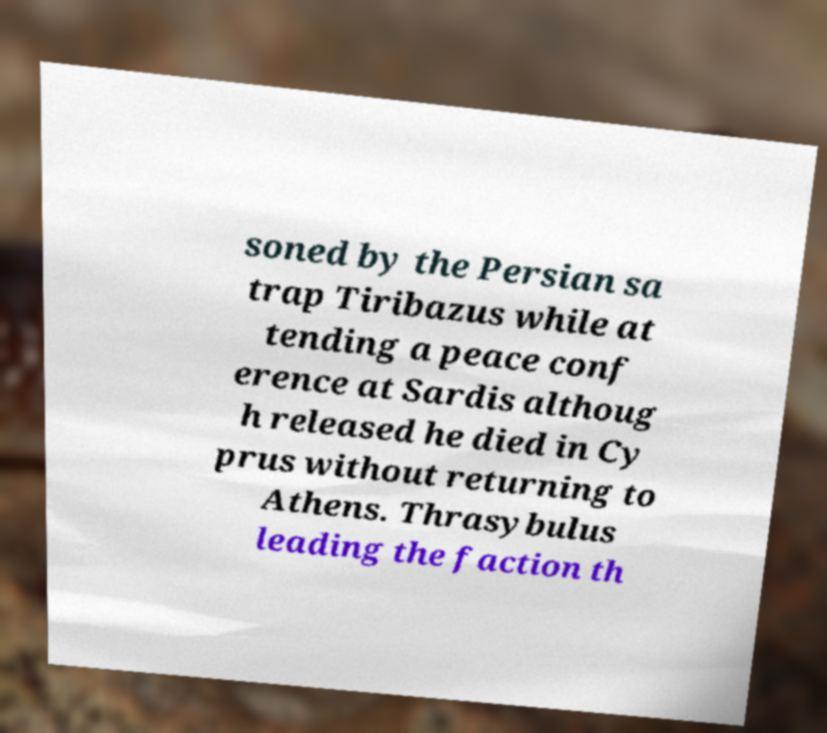Could you assist in decoding the text presented in this image and type it out clearly? soned by the Persian sa trap Tiribazus while at tending a peace conf erence at Sardis althoug h released he died in Cy prus without returning to Athens. Thrasybulus leading the faction th 